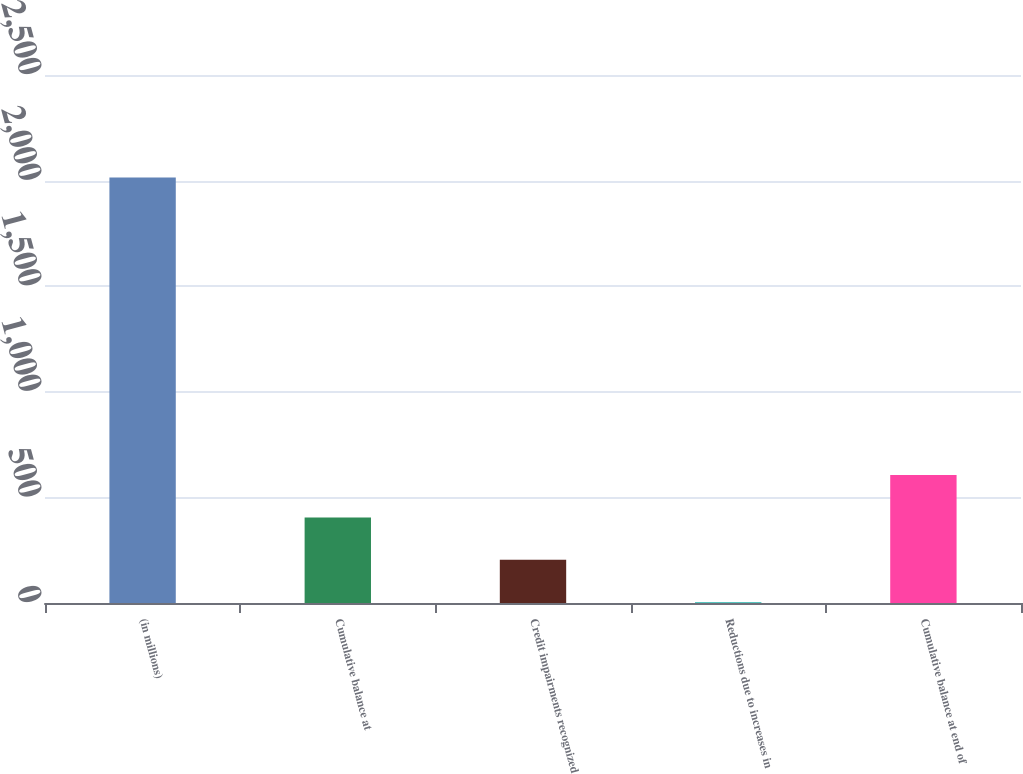<chart> <loc_0><loc_0><loc_500><loc_500><bar_chart><fcel>(in millions)<fcel>Cumulative balance at<fcel>Credit impairments recognized<fcel>Reductions due to increases in<fcel>Cumulative balance at end of<nl><fcel>2015<fcel>405.4<fcel>204.2<fcel>3<fcel>606.6<nl></chart> 